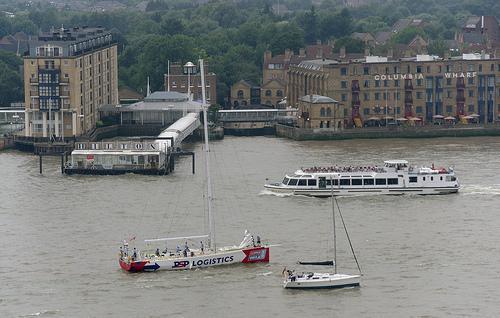How many boats are in the water?
Give a very brief answer. 3. How many boat are in the water?
Give a very brief answer. 3. How many boats are shown?
Give a very brief answer. 3. How many types of boats are shown?
Give a very brief answer. 3. How many sizes of boats are shown?
Give a very brief answer. 3. How many stories of the building are visible? (Counting the windows)?
Give a very brief answer. 6. 